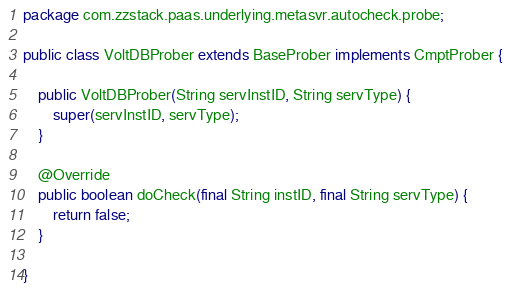<code> <loc_0><loc_0><loc_500><loc_500><_Java_>package com.zzstack.paas.underlying.metasvr.autocheck.probe;

public class VoltDBProber extends BaseProber implements CmptProber {

    public VoltDBProber(String servInstID, String servType) {
        super(servInstID, servType);
    }

    @Override
    public boolean doCheck(final String instID, final String servType) {
        return false;
    }

}
</code> 